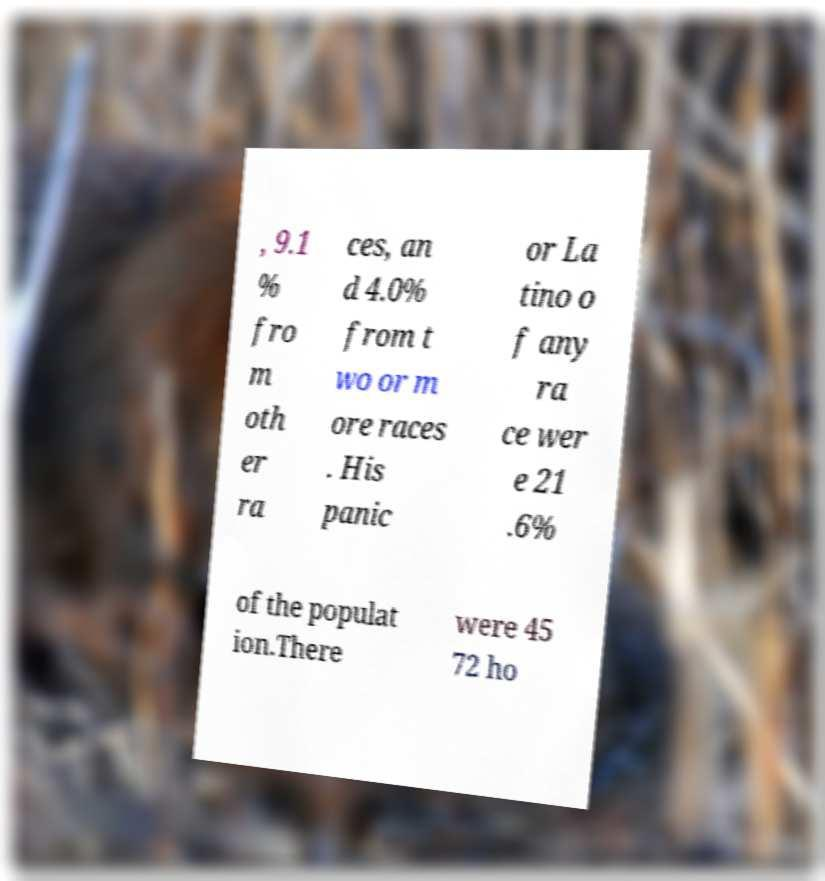Please identify and transcribe the text found in this image. , 9.1 % fro m oth er ra ces, an d 4.0% from t wo or m ore races . His panic or La tino o f any ra ce wer e 21 .6% of the populat ion.There were 45 72 ho 